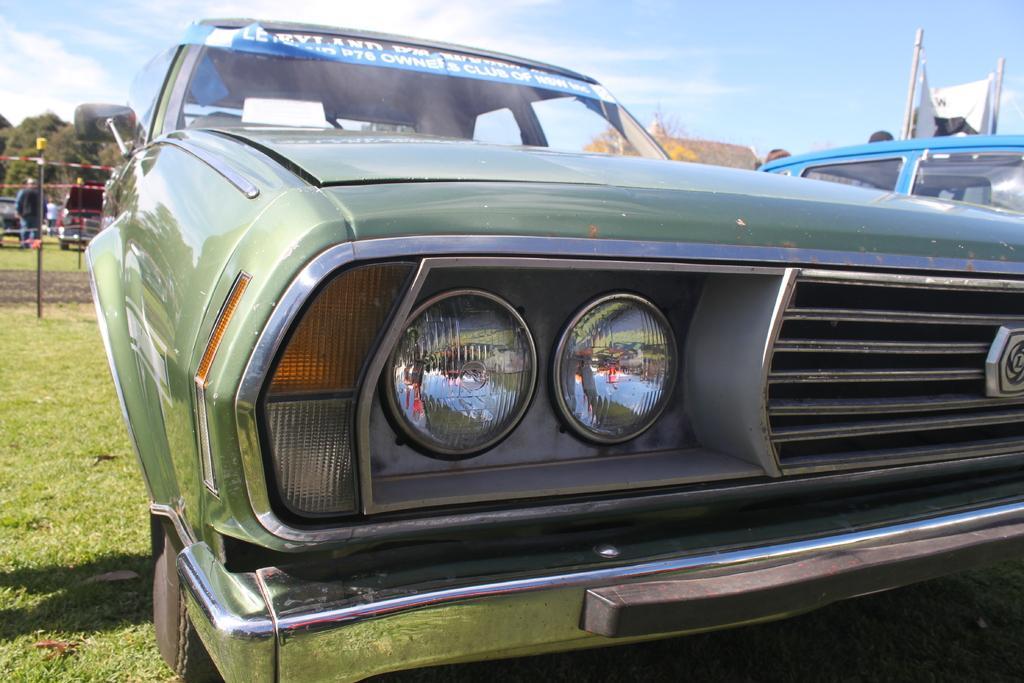How would you summarize this image in a sentence or two? In this image we can see sky with clouds, trees, poles, persons and motor vehicles on the ground. 